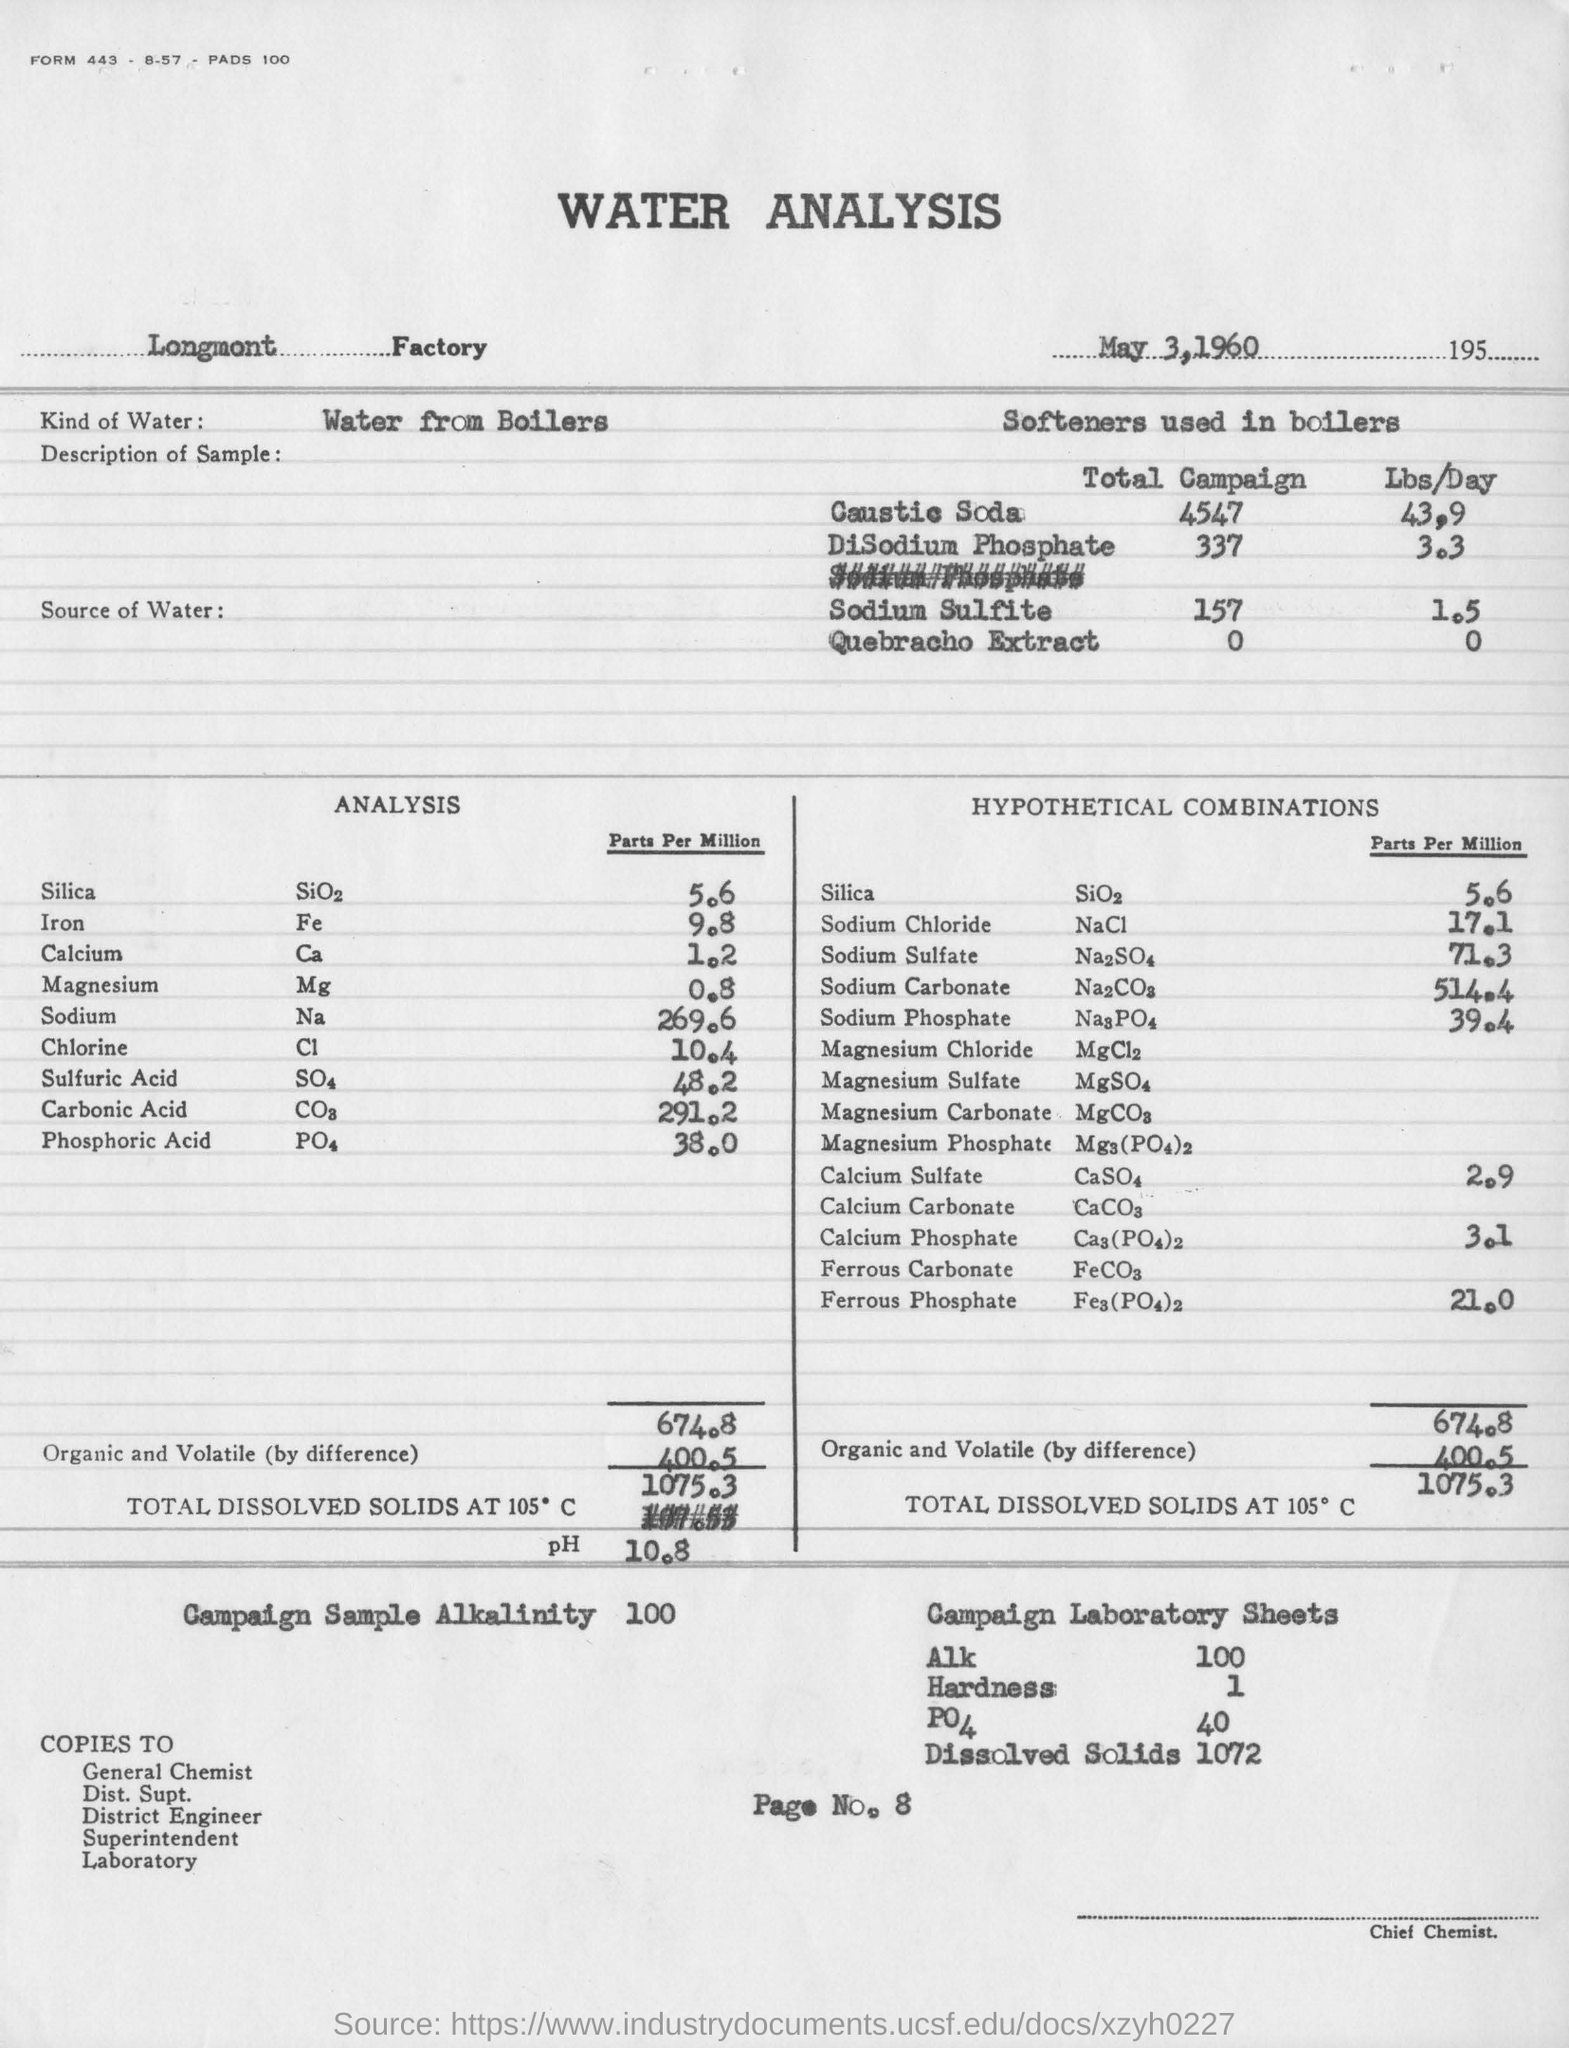Point out several critical features in this image. The page number of this document is 8. The analysis revealed that 5.6 parts per million of Silica were present. The water analysis was conducted at the Longmont Factory. The water used in the analysis was from the boilers. The document titled "Water Analysis," with a date of May 3, 1960, was created. 